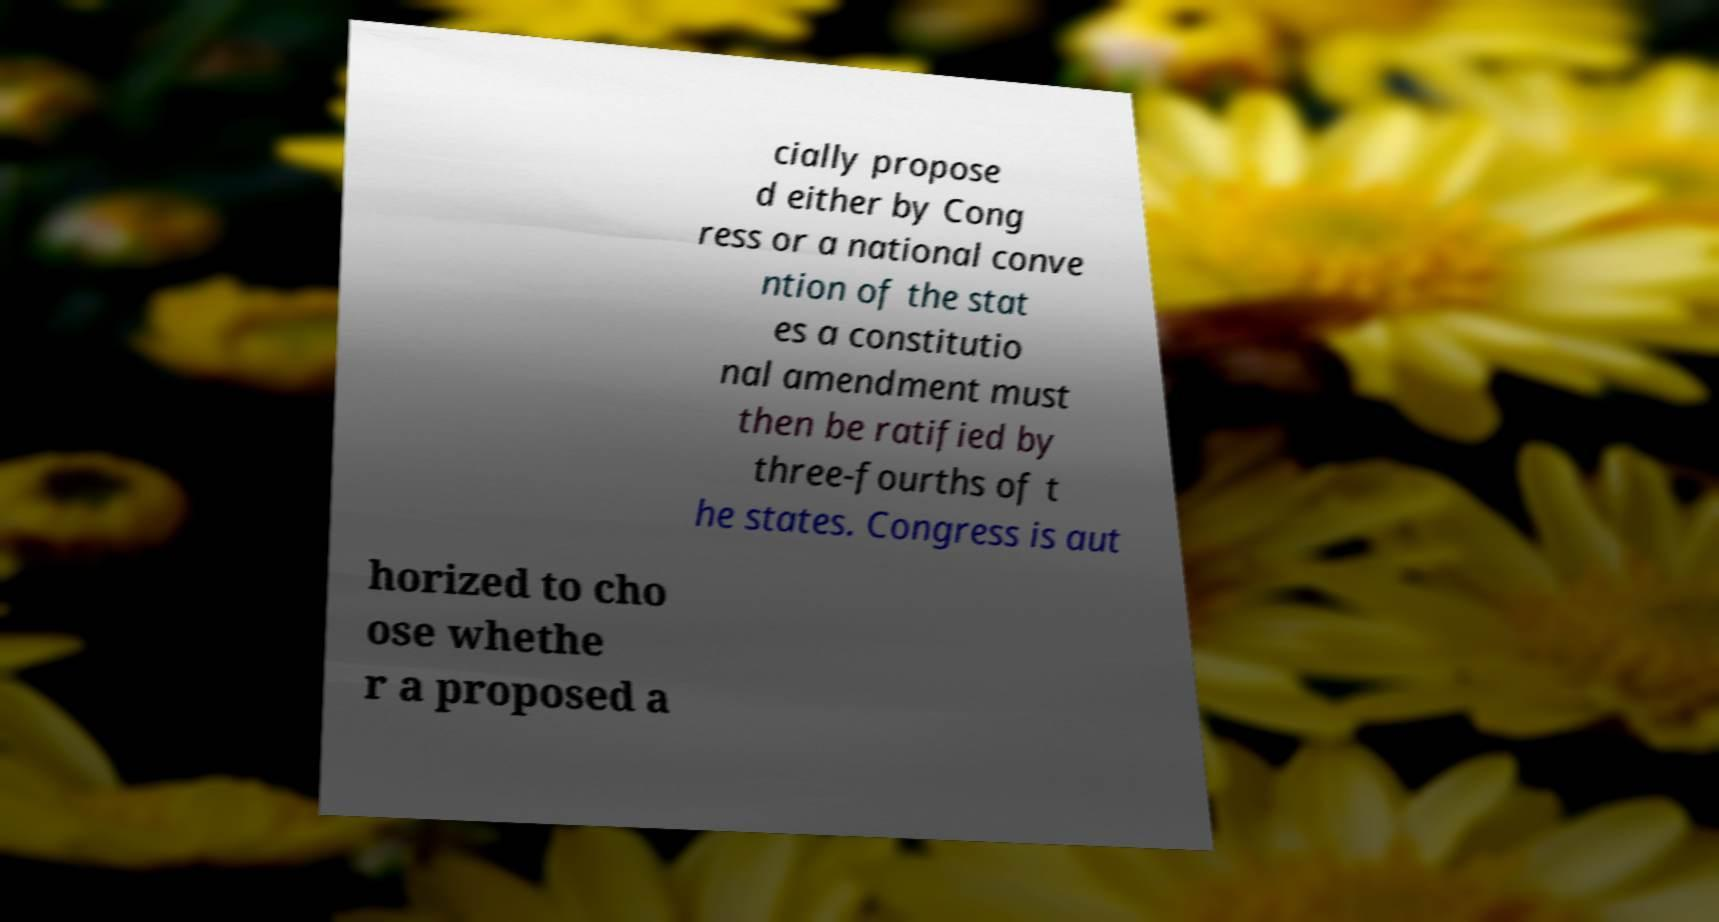Could you extract and type out the text from this image? cially propose d either by Cong ress or a national conve ntion of the stat es a constitutio nal amendment must then be ratified by three-fourths of t he states. Congress is aut horized to cho ose whethe r a proposed a 